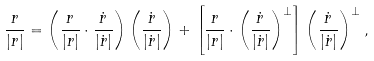<formula> <loc_0><loc_0><loc_500><loc_500>\frac { r } { | { r } | } = \left ( \frac { r } { | { r } | } \cdot \frac { \dot { r } } { | \dot { r } | } \right ) \left ( \frac { \dot { r } } { | \dot { r } | } \right ) + \left [ \frac { r } { | { r } | } \cdot \left ( \frac { \dot { r } } { | \dot { r } | } \right ) ^ { \perp } \right ] \left ( \frac { \dot { r } } { | \dot { r } | } \right ) ^ { \perp } ,</formula> 